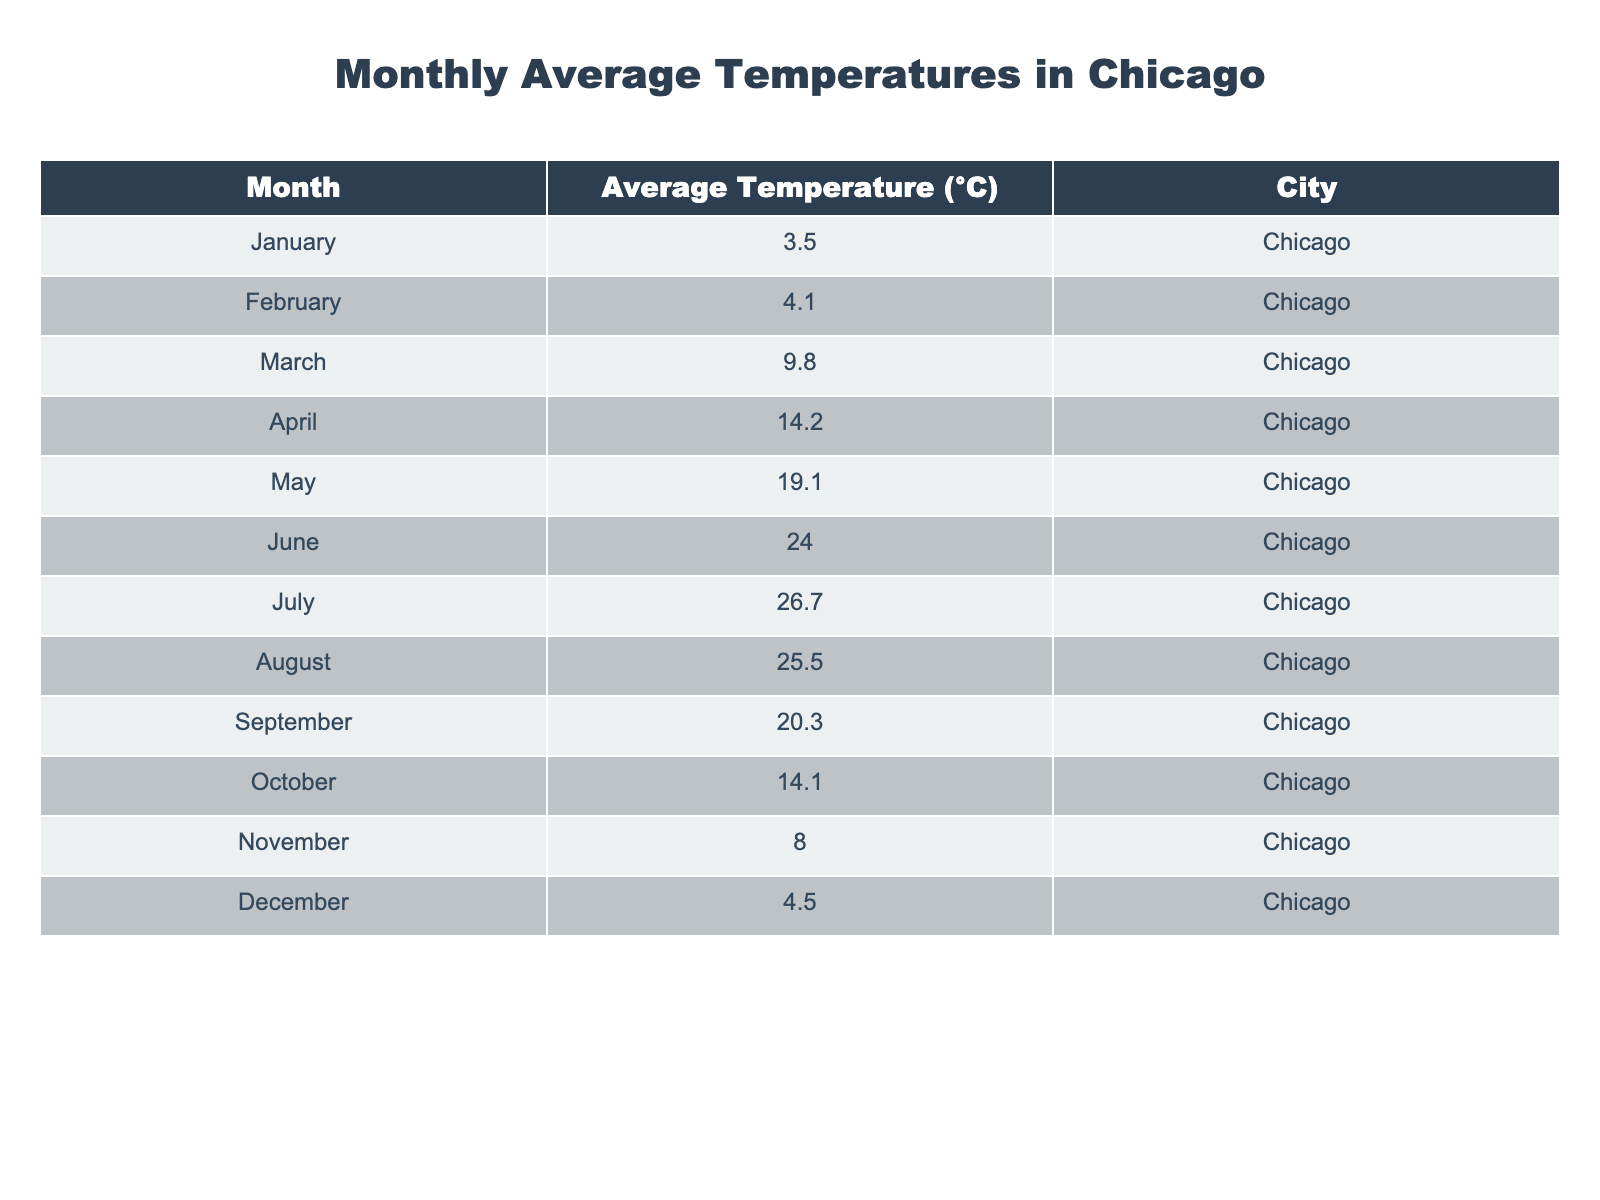What is the average temperature in Chicago in July? From the table, the average temperature in July is specifically listed as 26.7°C.
Answer: 26.7°C Which month had the highest average temperature? The table shows the monthly average temperatures, and the highest temperature is 26.7°C in July.
Answer: July What is the average temperature for the months of January and February combined? First, sum the average temperatures for January (3.5°C) and February (4.1°C): 3.5 + 4.1 = 7.6°C. Then, divide by 2 to find the average: 7.6 / 2 = 3.8°C.
Answer: 3.8°C In which month did the average temperature drop below 5°C? Looking through the table, January (3.5°C) and December (4.5°C) both had average temperatures below 5°C.
Answer: January and December What is the difference between the highest and lowest average temperatures? The highest average temperature is in July (26.7°C) and the lowest is in January (3.5°C). Calculating the difference: 26.7 - 3.5 = 23.2°C.
Answer: 23.2°C Which month had the second highest average temperature? To determine this, we look at the table and see that July (26.7°C) has the highest, and August (25.5°C) is the next highest.
Answer: August Are there any months where the average temperature was below 10°C? Analyzing the data, the months of January (3.5°C), February (4.1°C), March (9.8°C), November (8.0°C), and December (4.5°C) all had average temperatures below 10°C.
Answer: Yes What is the total average temperature for the first half of the year (January to June)? To find this, sum the average temperatures from January (3.5°C), February (4.1°C), March (9.8°C), April (14.2°C), May (19.1°C), and June (24.0°C): 3.5 + 4.1 + 9.8 + 14.2 + 19.1 + 24.0 = 74.7°C. Then, divide by 6 to get the average: 74.7 / 6 = 12.45°C.
Answer: 12.45°C What was the average temperature in the month following the coldest month? The coldest month is January (3.5°C), and the month following it is February, which has an average temperature of 4.1°C.
Answer: 4.1°C Was the temperature in September higher or lower than the average temperature in April? The average temperature in September is 20.3°C and in April it is 14.2°C. Since 20.3°C is greater than 14.2°C, September is higher.
Answer: Higher 